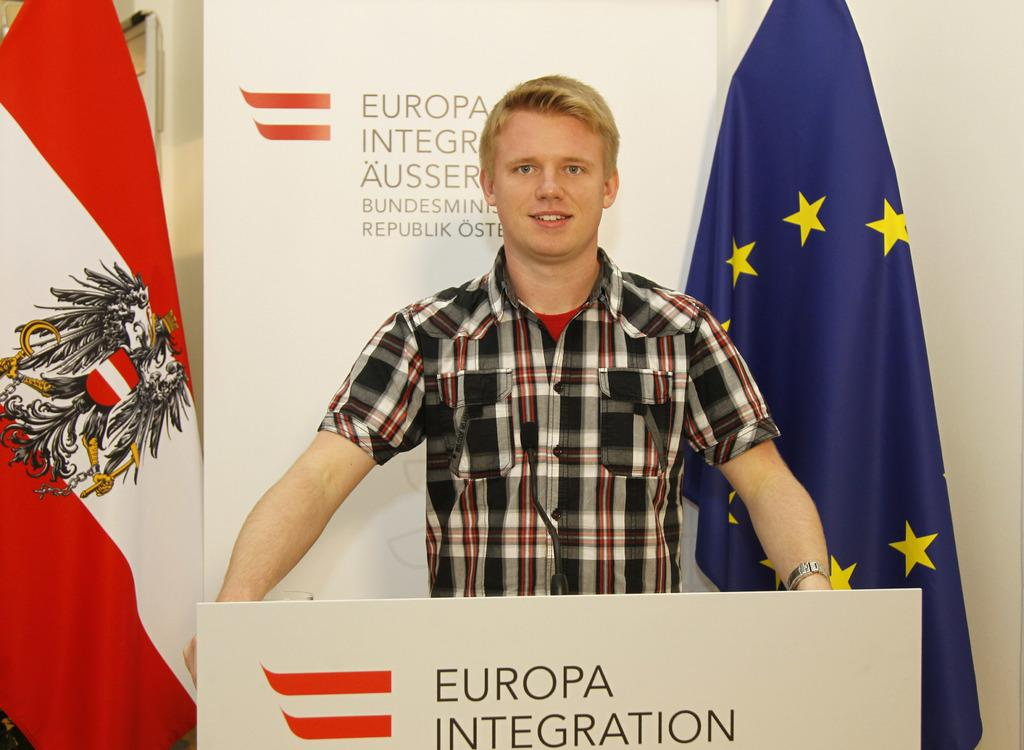What is located at the bottom of the image? There is a podium with a mic at the bottom of the image. Who is standing behind the podium? A boy is standing behind the podium. What can be seen behind the boy? There is a poster behind the boy. What other items are visible in the image? There are flags visible in the image. What type of meal is being prepared by the carpenter in the image? There is no carpenter or meal present in the image. Can you describe the lake visible in the background of the image? There is no lake visible in the image; it features a podium, a boy, a poster, and flags. 